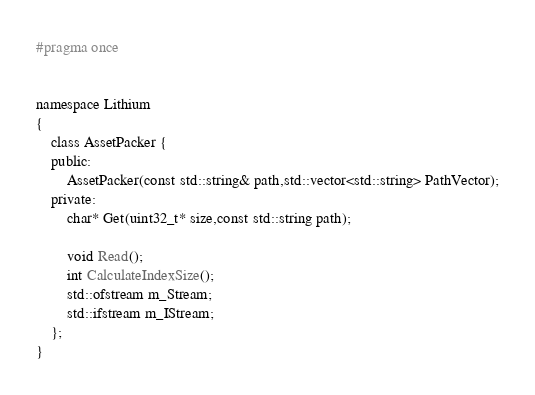<code> <loc_0><loc_0><loc_500><loc_500><_C_>#pragma once


namespace Lithium
{
	class AssetPacker {
	public:
		AssetPacker(const std::string& path,std::vector<std::string> PathVector);
	private:
		char* Get(uint32_t* size,const std::string path);
	
		void Read();
		int CalculateIndexSize();
		std::ofstream m_Stream;
		std::ifstream m_IStream;
	};
}</code> 